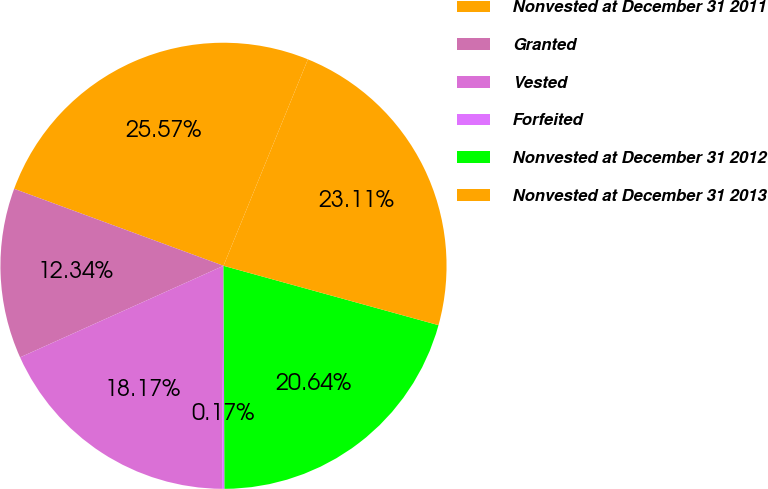Convert chart. <chart><loc_0><loc_0><loc_500><loc_500><pie_chart><fcel>Nonvested at December 31 2011<fcel>Granted<fcel>Vested<fcel>Forfeited<fcel>Nonvested at December 31 2012<fcel>Nonvested at December 31 2013<nl><fcel>25.57%<fcel>12.34%<fcel>18.17%<fcel>0.17%<fcel>20.64%<fcel>23.11%<nl></chart> 